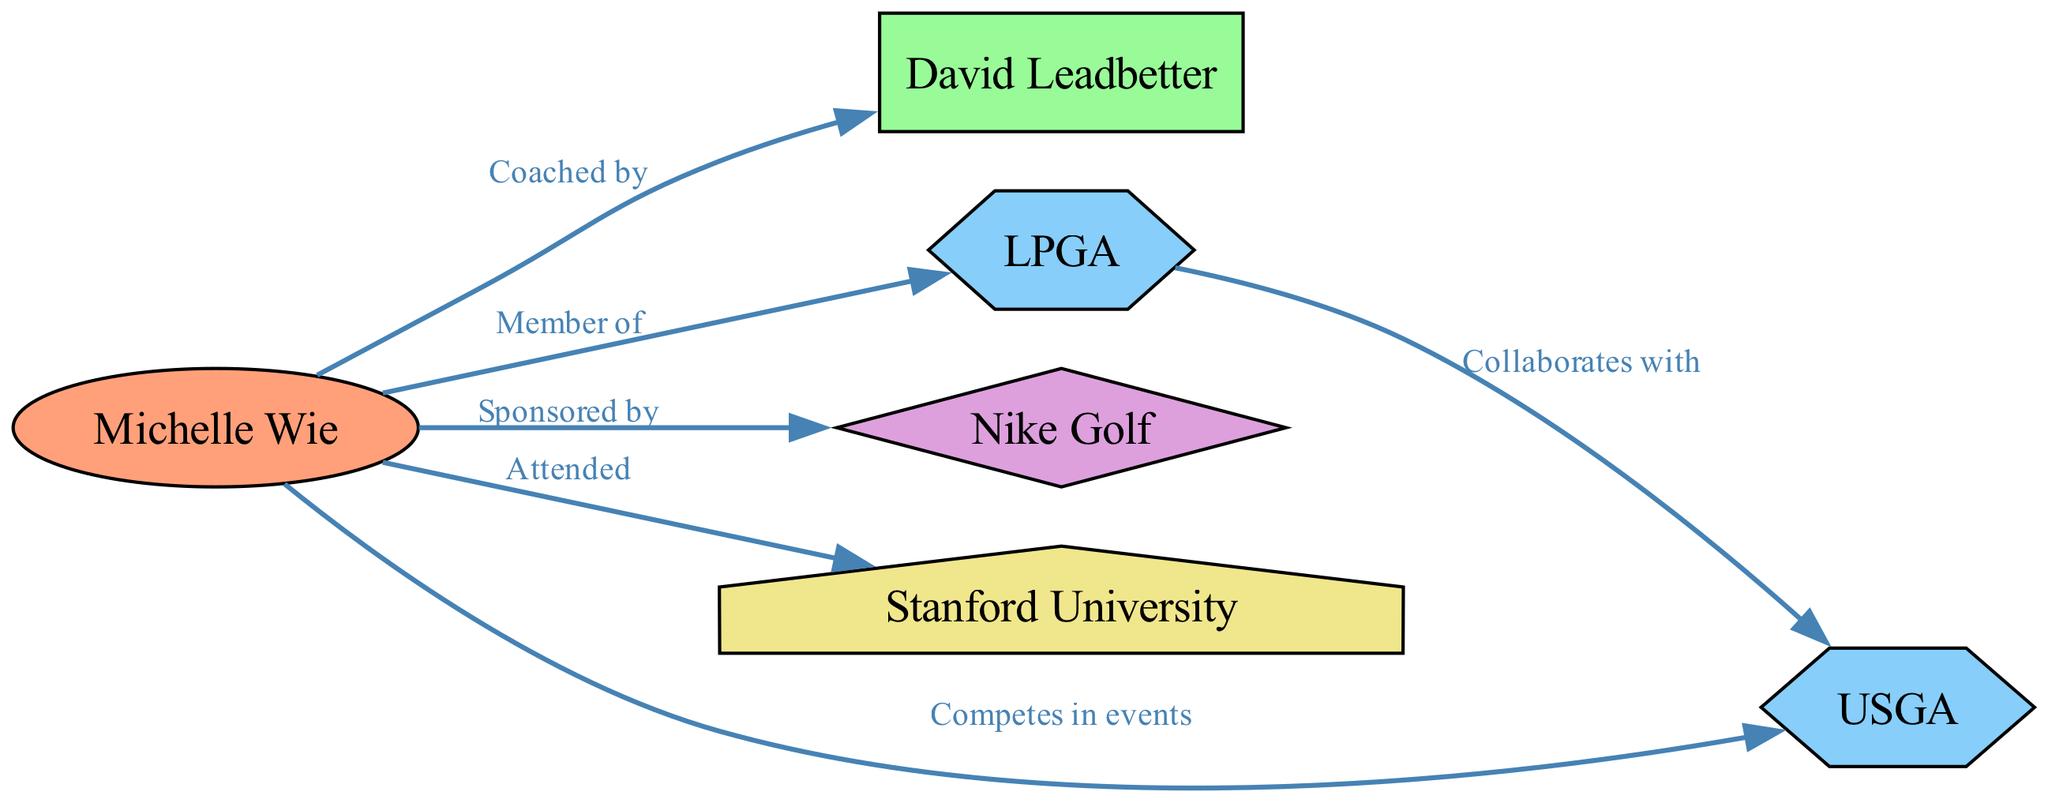What is the total number of nodes in the diagram? The diagram contains six nodes: Michelle Wie, David Leadbetter, LPGA, Nike Golf, Stanford University, and USGA. By counting them, we arrive at the total number.
Answer: 6 Who is coached by David Leadbetter? According to the edge labeled "Coached by," Michelle Wie is the Professional Golfer associated with David Leadbetter.
Answer: Michelle Wie Which organization does Michelle Wie compete in events with? The edge labeled "Competes in events" connects Michelle Wie to USGA, indicating that she competes in events organized by this body.
Answer: USGA How many organizations are represented in the diagram? The diagram comprises two organizations: LPGA and USGA. These can be identified in the nodes section of the diagram.
Answer: 2 Which sponsor is associated with Michelle Wie? The edge labeled "Sponsored by" indicates that Michelle Wie is associated with Nike Golf as her sponsor.
Answer: Nike Golf What is the relationship between LPGA and USGA? The edge labeled "Collaborates with" signifies that LPGA and USGA have a collaborative relationship, connecting the two organizations in the diagram.
Answer: Collaborates with Which educational institution did Michelle Wie attend? The edge labeled "Attended" connects Michelle Wie to Stanford University, indicating that she is a graduate of this educational institution.
Answer: Stanford University How many edges are present in the diagram? By counting the edges listed in the connection data, we see that there are five edges showing the relationships among the nodes in the diagram.
Answer: 5 What type is Michelle Wie classified as in the diagram? In the diagram, Michelle Wie is specifically classified as a "Professional Golfer," as indicated in her node type.
Answer: Professional Golfer 